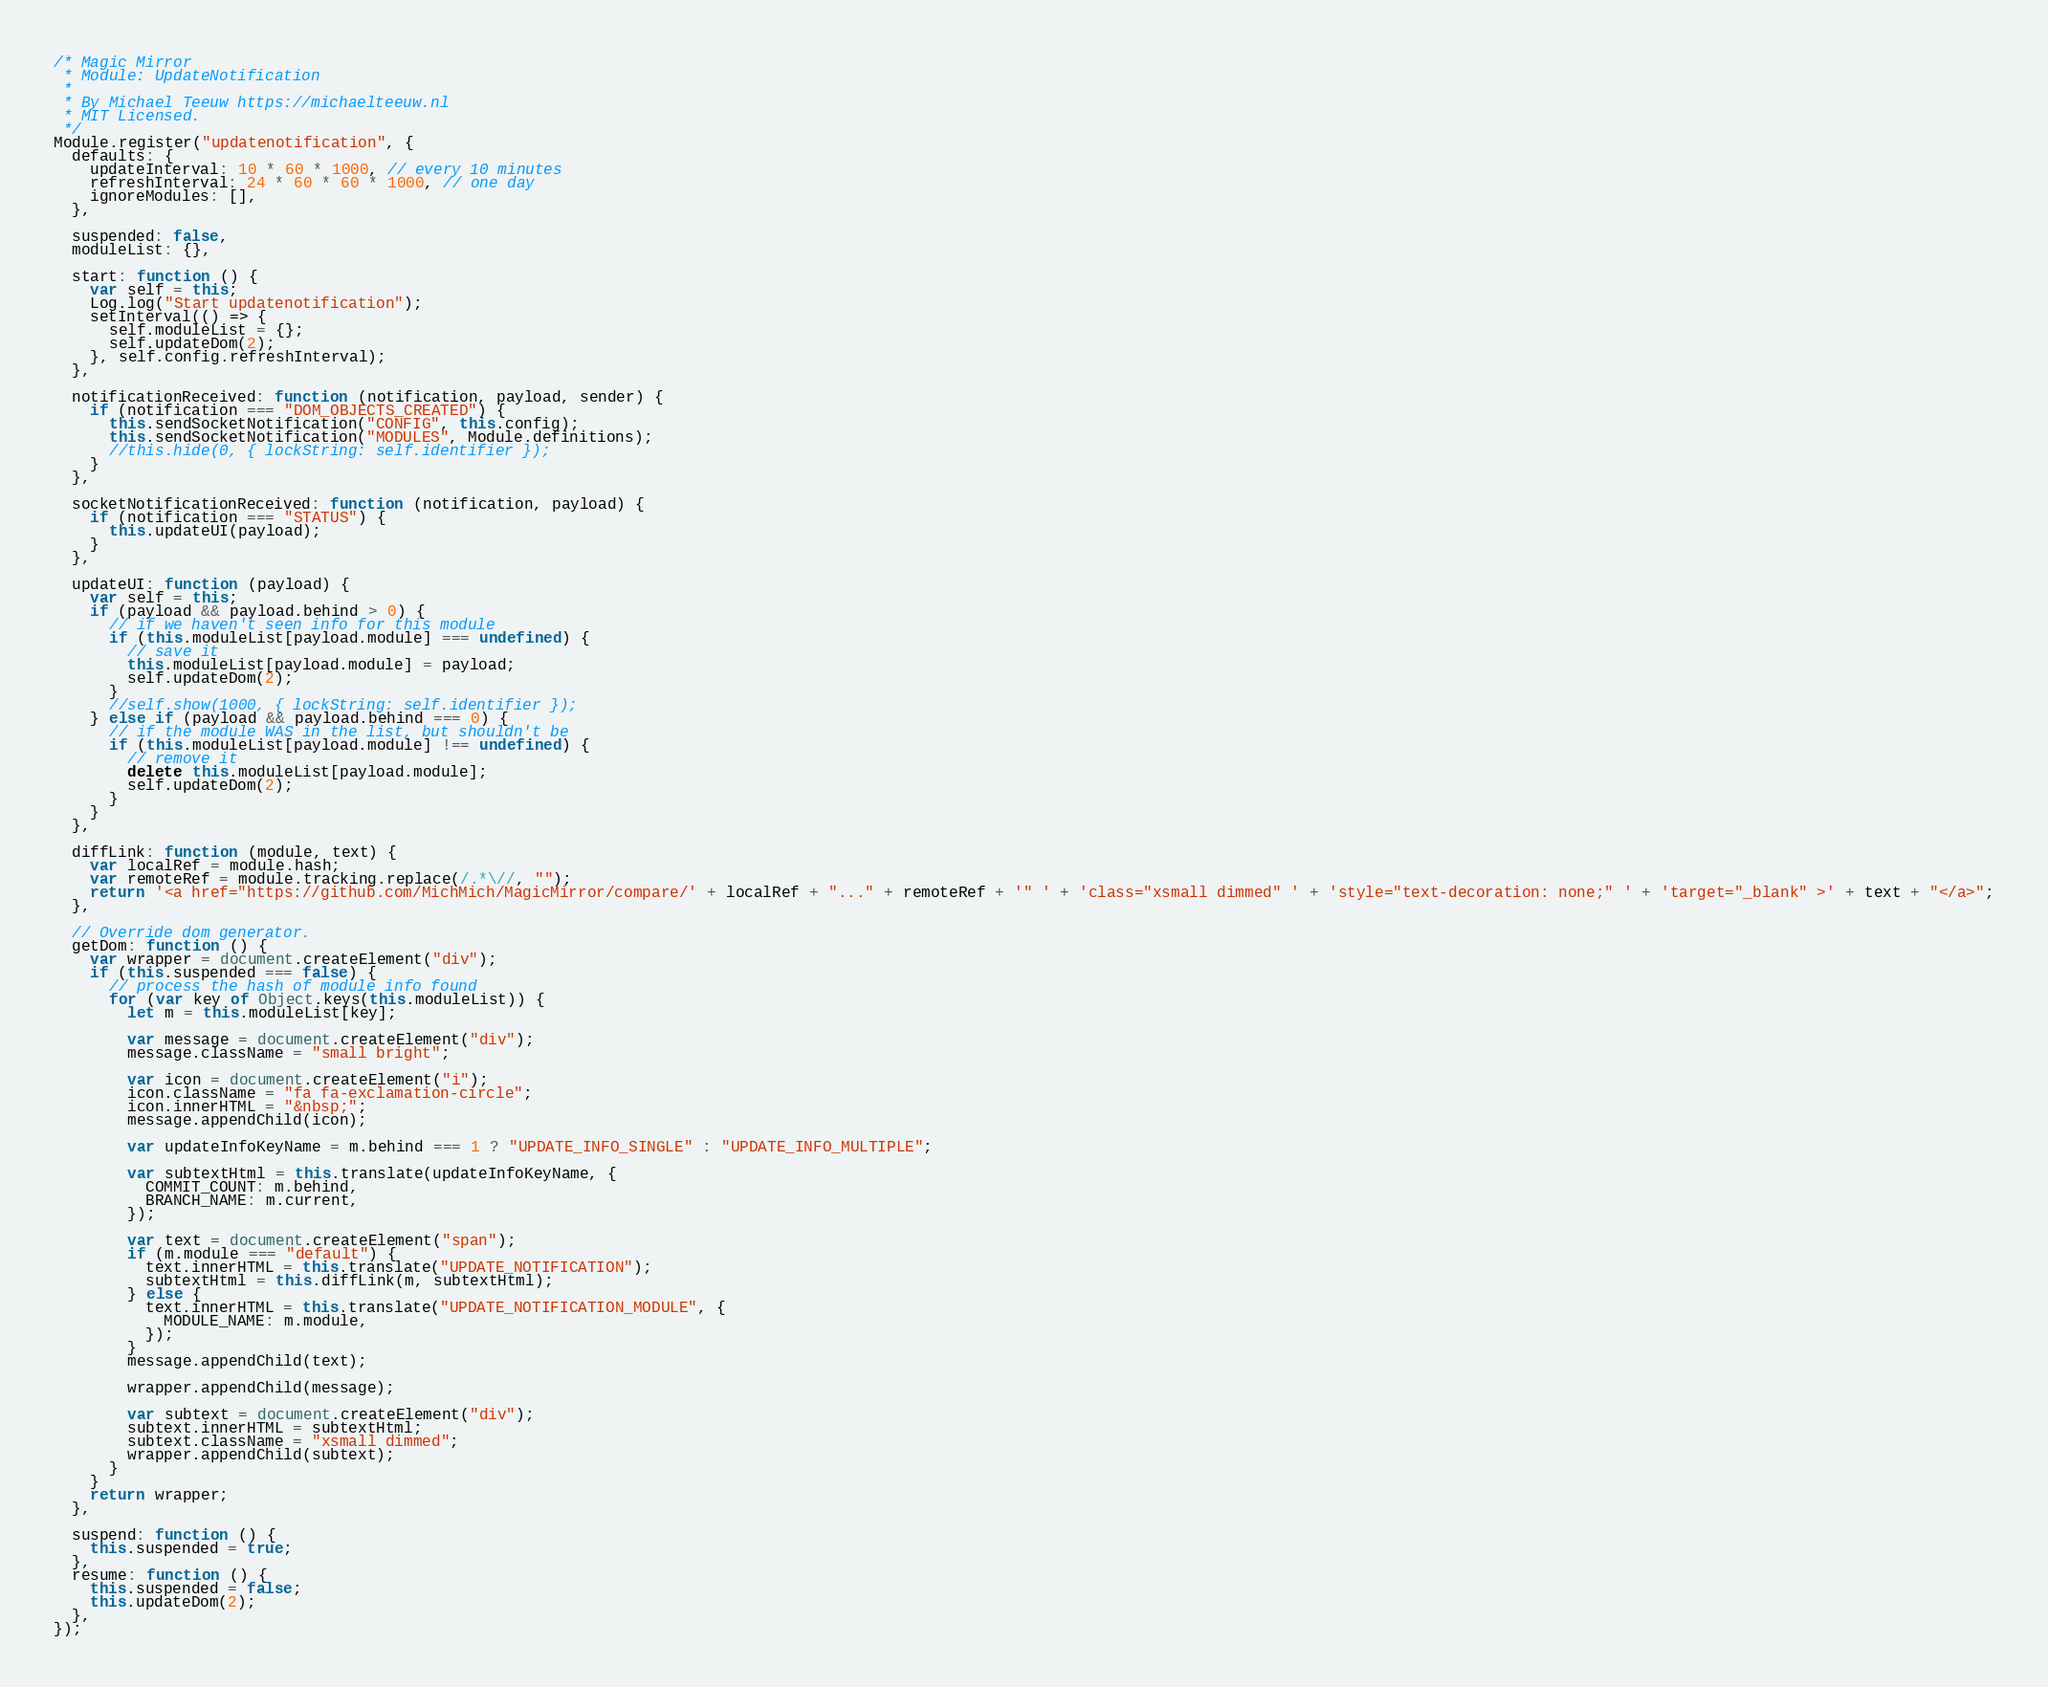<code> <loc_0><loc_0><loc_500><loc_500><_JavaScript_>/* Magic Mirror
 * Module: UpdateNotification
 *
 * By Michael Teeuw https://michaelteeuw.nl
 * MIT Licensed.
 */
Module.register("updatenotification", {
  defaults: {
    updateInterval: 10 * 60 * 1000, // every 10 minutes
    refreshInterval: 24 * 60 * 60 * 1000, // one day
    ignoreModules: [],
  },

  suspended: false,
  moduleList: {},

  start: function () {
    var self = this;
    Log.log("Start updatenotification");
    setInterval(() => {
      self.moduleList = {};
      self.updateDom(2);
    }, self.config.refreshInterval);
  },

  notificationReceived: function (notification, payload, sender) {
    if (notification === "DOM_OBJECTS_CREATED") {
      this.sendSocketNotification("CONFIG", this.config);
      this.sendSocketNotification("MODULES", Module.definitions);
      //this.hide(0, { lockString: self.identifier });
    }
  },

  socketNotificationReceived: function (notification, payload) {
    if (notification === "STATUS") {
      this.updateUI(payload);
    }
  },

  updateUI: function (payload) {
    var self = this;
    if (payload && payload.behind > 0) {
      // if we haven't seen info for this module
      if (this.moduleList[payload.module] === undefined) {
        // save it
        this.moduleList[payload.module] = payload;
        self.updateDom(2);
      }
      //self.show(1000, { lockString: self.identifier });
    } else if (payload && payload.behind === 0) {
      // if the module WAS in the list, but shouldn't be
      if (this.moduleList[payload.module] !== undefined) {
        // remove it
        delete this.moduleList[payload.module];
        self.updateDom(2);
      }
    }
  },

  diffLink: function (module, text) {
    var localRef = module.hash;
    var remoteRef = module.tracking.replace(/.*\//, "");
    return '<a href="https://github.com/MichMich/MagicMirror/compare/' + localRef + "..." + remoteRef + '" ' + 'class="xsmall dimmed" ' + 'style="text-decoration: none;" ' + 'target="_blank" >' + text + "</a>";
  },

  // Override dom generator.
  getDom: function () {
    var wrapper = document.createElement("div");
    if (this.suspended === false) {
      // process the hash of module info found
      for (var key of Object.keys(this.moduleList)) {
        let m = this.moduleList[key];

        var message = document.createElement("div");
        message.className = "small bright";

        var icon = document.createElement("i");
        icon.className = "fa fa-exclamation-circle";
        icon.innerHTML = "&nbsp;";
        message.appendChild(icon);

        var updateInfoKeyName = m.behind === 1 ? "UPDATE_INFO_SINGLE" : "UPDATE_INFO_MULTIPLE";

        var subtextHtml = this.translate(updateInfoKeyName, {
          COMMIT_COUNT: m.behind,
          BRANCH_NAME: m.current,
        });

        var text = document.createElement("span");
        if (m.module === "default") {
          text.innerHTML = this.translate("UPDATE_NOTIFICATION");
          subtextHtml = this.diffLink(m, subtextHtml);
        } else {
          text.innerHTML = this.translate("UPDATE_NOTIFICATION_MODULE", {
            MODULE_NAME: m.module,
          });
        }
        message.appendChild(text);

        wrapper.appendChild(message);

        var subtext = document.createElement("div");
        subtext.innerHTML = subtextHtml;
        subtext.className = "xsmall dimmed";
        wrapper.appendChild(subtext);
      }
    }
    return wrapper;
  },

  suspend: function () {
    this.suspended = true;
  },
  resume: function () {
    this.suspended = false;
    this.updateDom(2);
  },
});
</code> 